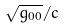Convert formula to latex. <formula><loc_0><loc_0><loc_500><loc_500>\sqrt { g _ { 0 0 } } / c</formula> 